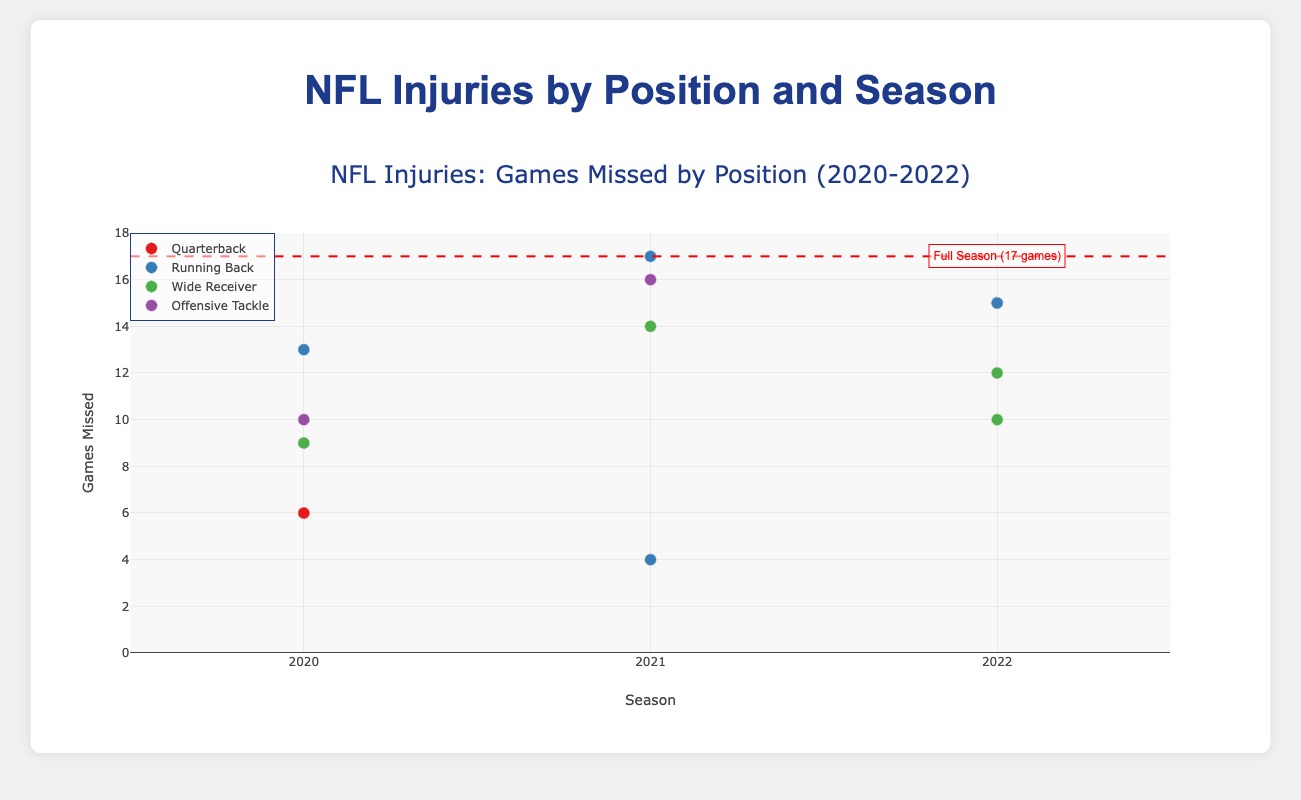What's the title of the figure? The title of the figure is located at the top center of the plot and typically provides a summary of what the plot is showing. In this case, it reads "NFL Injuries: Games Missed by Position (2020-2022)"
Answer: NFL Injuries: Games Missed by Position (2020-2022) How many players are presented in total across all seasons in the plot? Each trace represents a different player with their injuries marked as points in the plot. Counting all the points from each season (2020, 2021, 2022), there are a total of 12 players.
Answer: 12 Which position has the highest total number of games missed in the 2020 season? To determine this, sum up the games missed by players of each position in 2020: Quarterback (6), Running Back (13), Wide Receiver (9), and Offensive Tackle (10). Running Back has the highest total.
Answer: Running Back Which season had the highest number of total games missed due to injuries? By adding up the games missed in each season: 2020 (6+13+9+10=38), 2021 (4+14+17+16=51), and 2022 (15+12+10+15=52), the 2022 season had the most total games missed.
Answer: 2022 Who missed the entire season, and in which year did it occur? The plot shows a red dashed line indicating a full season (17 games). The only player whose point is marked at this line is J.K. Dobbins from the 2021 season.
Answer: J.K. Dobbins, 2021 Which injury type caused the most games missed in the 2021 season? From examining the hover texts for the 2021 season, we see that the injury with the highest games missed was "Torn ACL", affecting J.K. Dobbins (17 games missed) and David Bakhtiari (16 games missed) for a total of 33 games.
Answer: Torn ACL Between quarterbacks from the 2020 and 2022 seasons, who missed more games and by how much? Joe Burrow (2020) missed 6 games, whereas Trey Lance (2022) missed 15 games. So, Trey Lance missed 15 - 6 = 9 more games.
Answer: Trey Lance, 9 Which player from the 2020 season missed the fewest games due to injury? From the 2020 season, Joe Burrow missed 6 games, the lowest among the players listed: Joe Burrow (6), Christian McCaffrey (13), Michael Thomas (9), and Ronnie Stanley (10).
Answer: Joe Burrow How many wide receivers are presented in the 2022 season, and how much did they miss in total? Looking at the 2022 season, Chris Godwin and Juju Smith-Schuster are the wide receivers, missing a total of 12 + 10 = 22 games.
Answer: 2 wide receivers, 22 games 